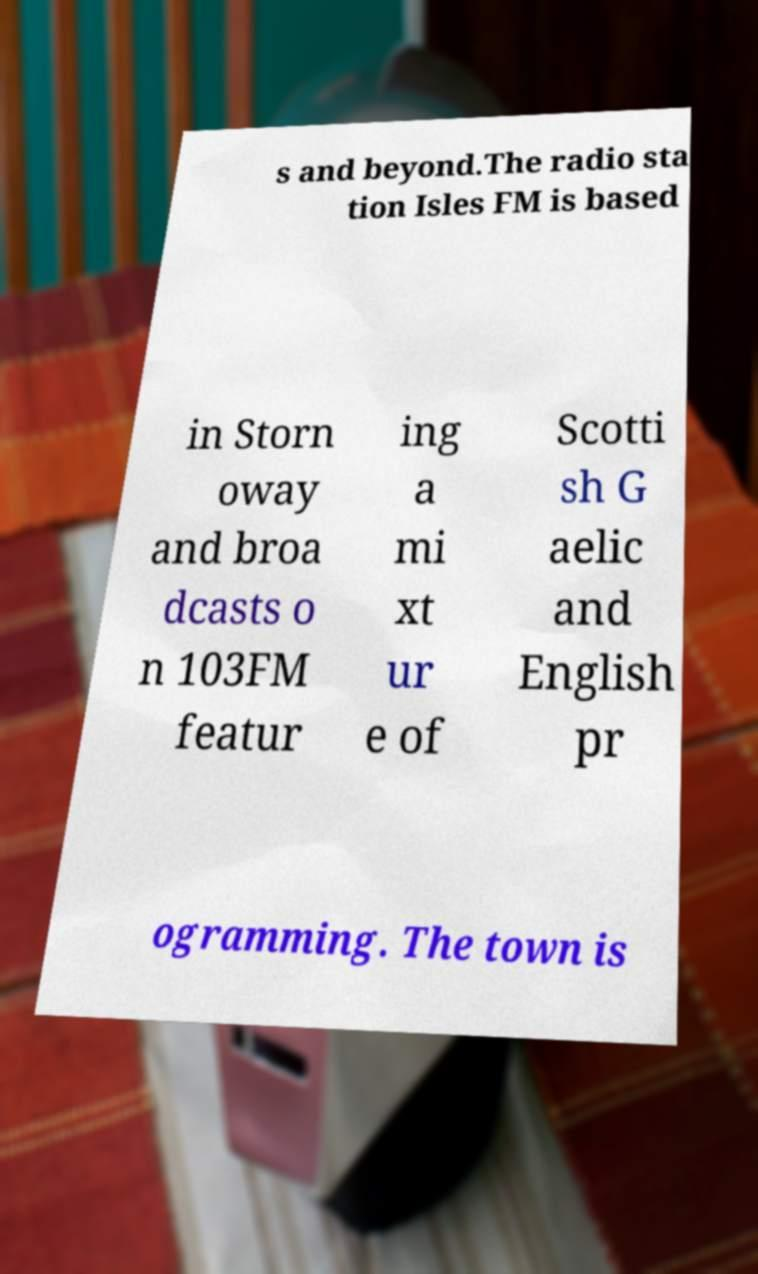There's text embedded in this image that I need extracted. Can you transcribe it verbatim? s and beyond.The radio sta tion Isles FM is based in Storn oway and broa dcasts o n 103FM featur ing a mi xt ur e of Scotti sh G aelic and English pr ogramming. The town is 